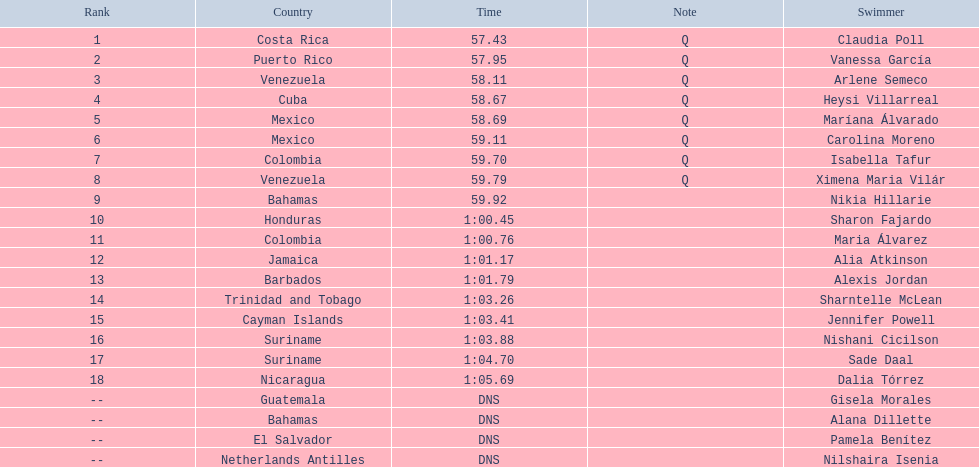Which swimmer had the longest time? Dalia Tórrez. 